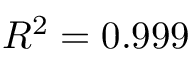<formula> <loc_0><loc_0><loc_500><loc_500>R ^ { 2 } = 0 . 9 9 9</formula> 